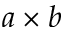<formula> <loc_0><loc_0><loc_500><loc_500>a \times b</formula> 